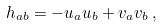Convert formula to latex. <formula><loc_0><loc_0><loc_500><loc_500>h _ { a b } = - u _ { a } u _ { b } + v _ { a } v _ { b } \, ,</formula> 